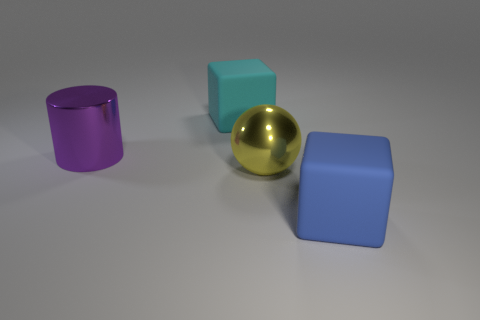There is a large cyan object that is the same material as the large blue object; what is its shape?
Provide a succinct answer. Cube. What is the cube that is in front of the large metallic object behind the large yellow ball made of?
Give a very brief answer. Rubber. There is a matte object to the left of the blue block; is it the same shape as the yellow metallic object?
Provide a succinct answer. No. Is the number of large cubes that are on the left side of the purple metallic cylinder greater than the number of big matte objects?
Your answer should be very brief. No. Is there any other thing that is the same material as the big blue block?
Your answer should be compact. Yes. What number of balls are either big cyan objects or matte objects?
Offer a very short reply. 0. What is the color of the large matte block that is behind the big shiny object that is on the left side of the big cyan matte thing?
Make the answer very short. Cyan. Do the sphere and the cube in front of the big cyan cube have the same color?
Make the answer very short. No. There is a yellow object that is made of the same material as the big purple thing; what size is it?
Ensure brevity in your answer.  Large. Is the sphere the same color as the cylinder?
Offer a terse response. No. 